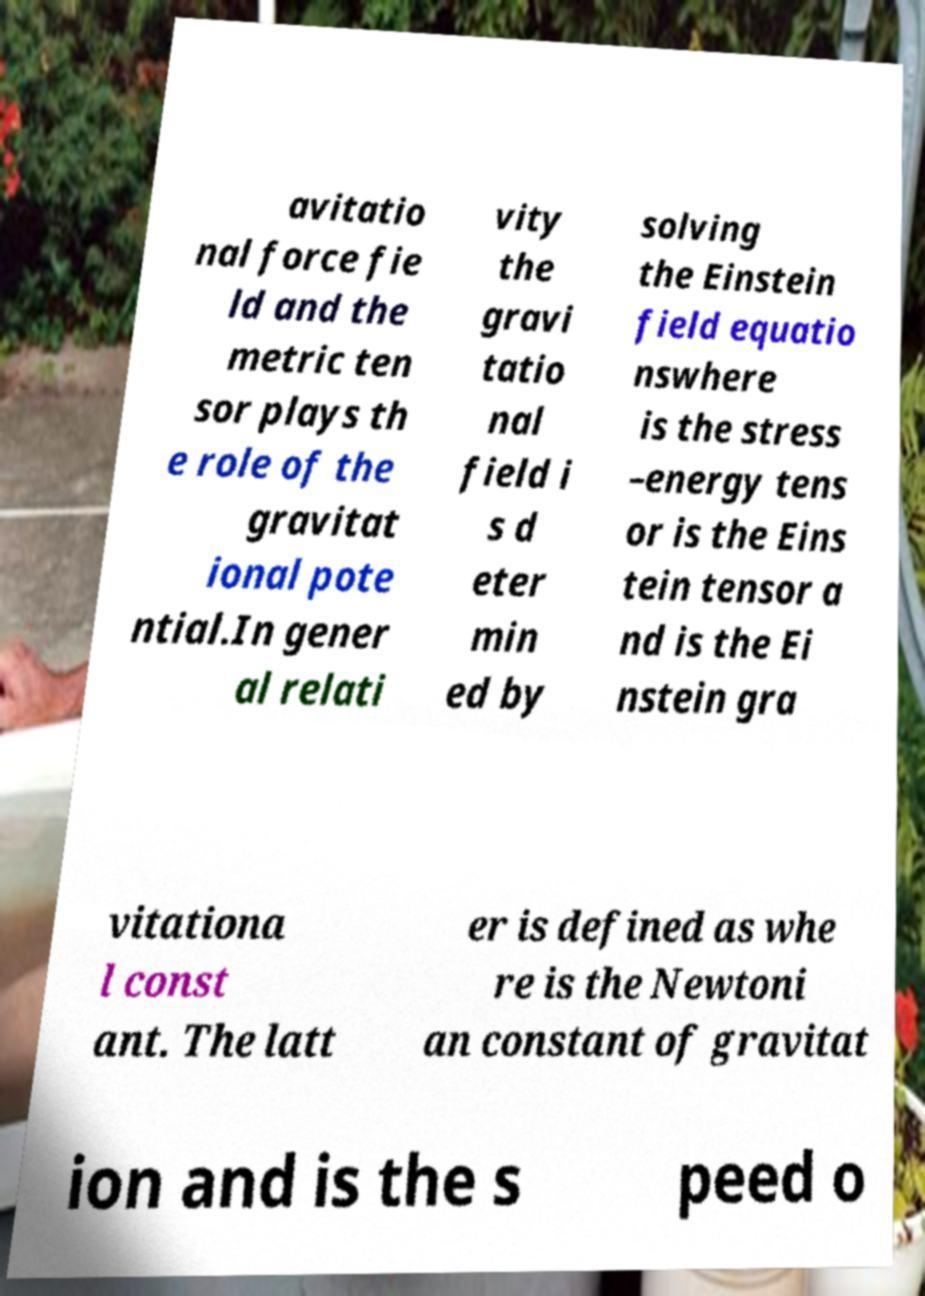Can you accurately transcribe the text from the provided image for me? avitatio nal force fie ld and the metric ten sor plays th e role of the gravitat ional pote ntial.In gener al relati vity the gravi tatio nal field i s d eter min ed by solving the Einstein field equatio nswhere is the stress –energy tens or is the Eins tein tensor a nd is the Ei nstein gra vitationa l const ant. The latt er is defined as whe re is the Newtoni an constant of gravitat ion and is the s peed o 